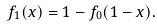Convert formula to latex. <formula><loc_0><loc_0><loc_500><loc_500>f _ { 1 } ( x ) = 1 - f _ { 0 } ( 1 - x ) .</formula> 